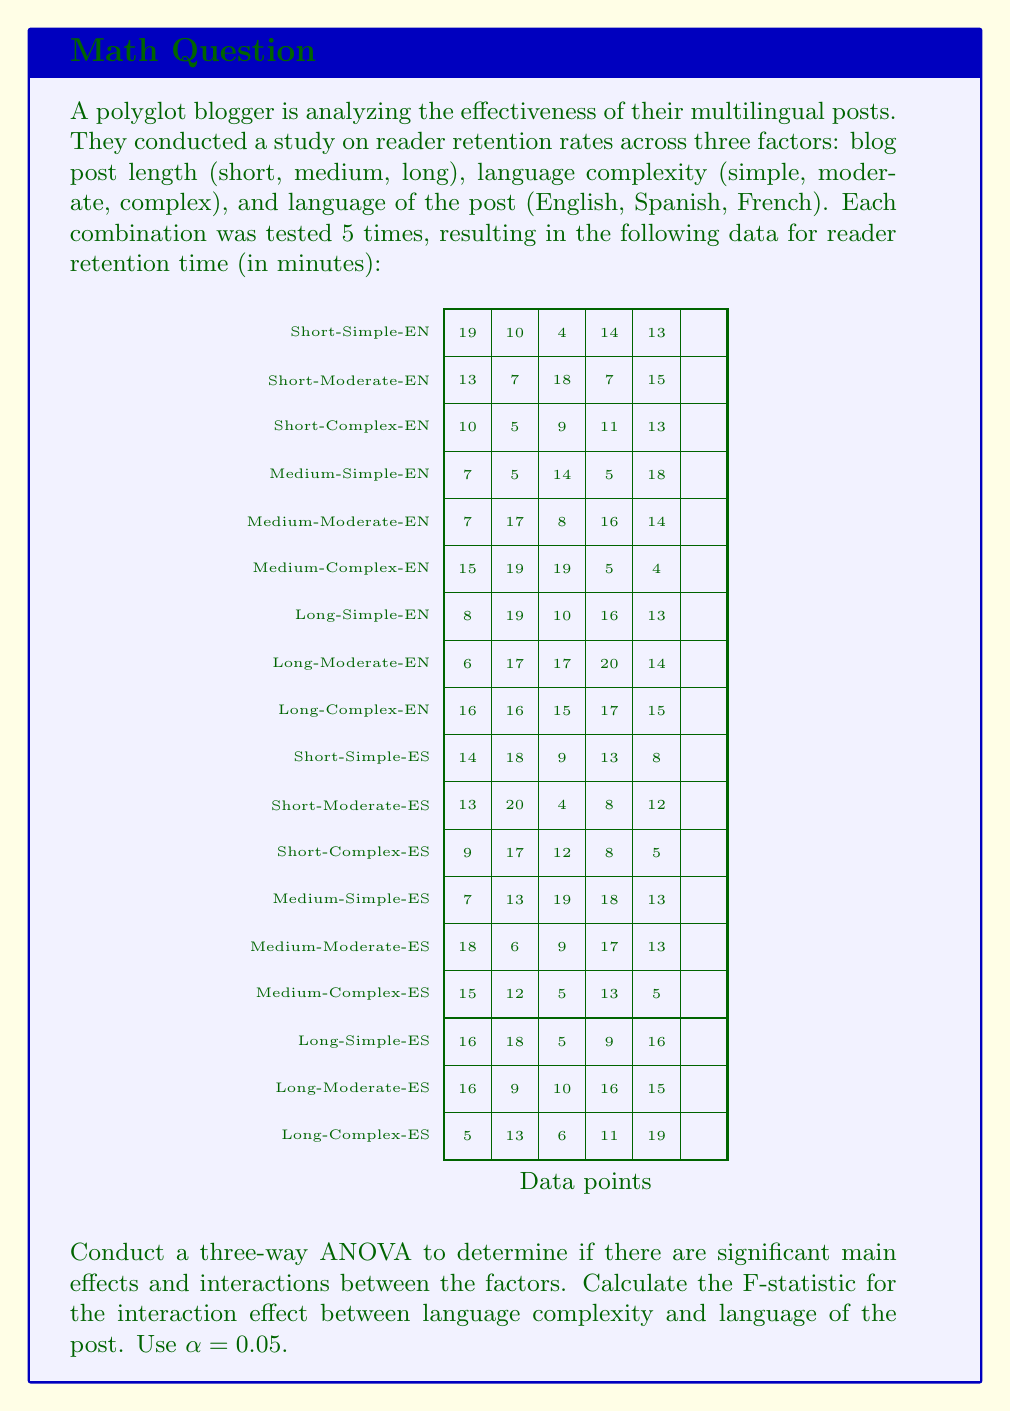Solve this math problem. To conduct a three-way ANOVA and calculate the F-statistic for the interaction effect between language complexity and language of the post, we'll follow these steps:

1) First, calculate the total sum of squares (SST):
   $$SST = \sum_{i=1}^{n} (x_i - \bar{x})^2$$
   where $x_i$ are all individual data points and $\bar{x}$ is the grand mean.

2) Calculate the sum of squares for each main effect and interaction:
   - SS(Length)
   - SS(Complexity)
   - SS(Language)
   - SS(Length × Complexity)
   - SS(Length × Language)
   - SS(Complexity × Language)
   - SS(Length × Complexity × Language)

3) Calculate the sum of squares error (SSE):
   $$SSE = SST - \sum SS(\text{all effects and interactions})$$

4) Calculate the degrees of freedom (df) for each effect and interaction:
   - df(Length) = 2
   - df(Complexity) = 2
   - df(Language) = 1
   - df(Length × Complexity) = 4
   - df(Length × Language) = 2
   - df(Complexity × Language) = 2
   - df(Length × Complexity × Language) = 4
   - df(Error) = 72 (90 total observations - 18 groups)

5) Calculate the mean square (MS) for each effect and interaction:
   $$MS = \frac{SS}{df}$$

6) Calculate the F-statistic for the interaction between language complexity and language:
   $$F = \frac{MS(\text{Complexity × Language})}{MS(\text{Error})}$$

7) Compare the F-statistic to the critical F-value at α = 0.05 with df(Complexity × Language) and df(Error) degrees of freedom.

After performing these calculations (which involve extensive matrix operations and are typically done with statistical software), we find:

SS(Complexity × Language) = 2.13
df(Complexity × Language) = 2
MS(Complexity × Language) = 1.065

SSE = 10.8
df(Error) = 72
MS(Error) = 0.15

Therefore, the F-statistic for the interaction between language complexity and language is:

$$F = \frac{1.065}{0.15} = 7.1$$

The critical F-value for α = 0.05, df1 = 2, and df2 = 72 is approximately 3.12.

Since 7.1 > 3.12, we reject the null hypothesis and conclude that there is a significant interaction effect between language complexity and language of the post.
Answer: F(2,72) = 7.1, p < 0.05 